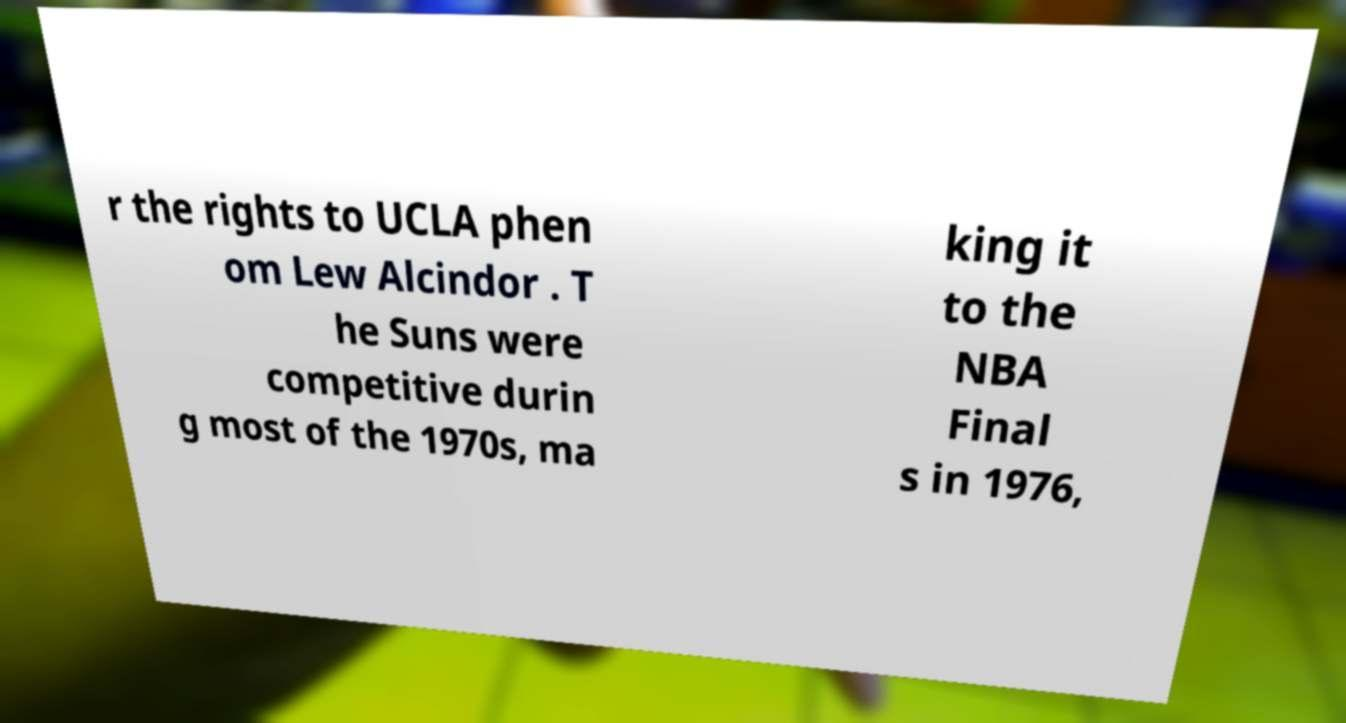Can you accurately transcribe the text from the provided image for me? r the rights to UCLA phen om Lew Alcindor . T he Suns were competitive durin g most of the 1970s, ma king it to the NBA Final s in 1976, 